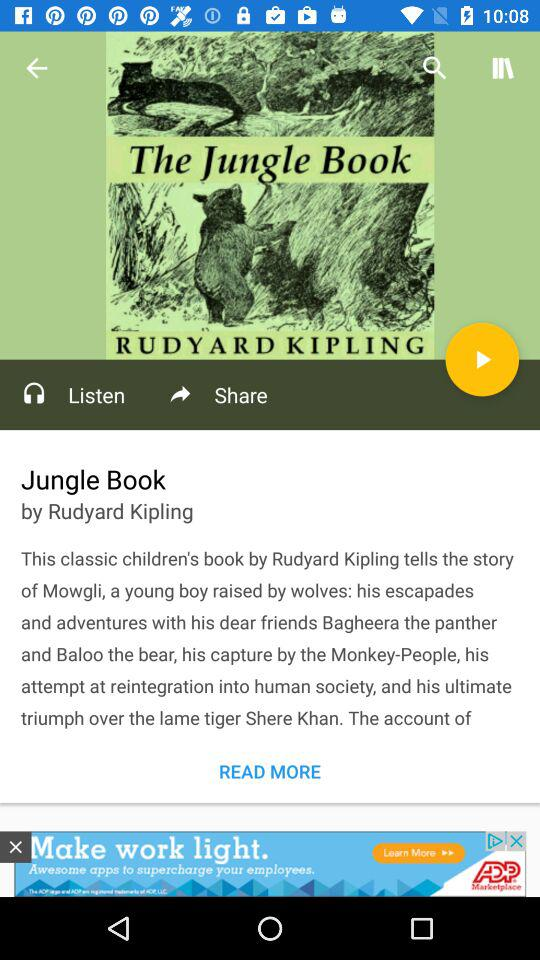Which sharing options are available for the book?
When the provided information is insufficient, respond with <no answer>. <no answer> 